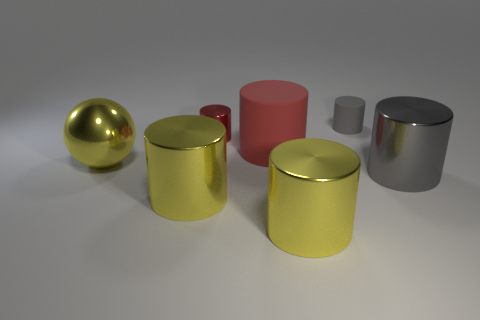Subtract all large rubber cylinders. How many cylinders are left? 5 Subtract all yellow cylinders. Subtract all green cubes. How many cylinders are left? 4 Add 1 purple rubber things. How many objects exist? 8 Subtract all cylinders. How many objects are left? 1 Add 4 tiny gray rubber cylinders. How many tiny gray rubber cylinders exist? 5 Subtract 0 gray spheres. How many objects are left? 7 Subtract all big yellow objects. Subtract all tiny green rubber objects. How many objects are left? 4 Add 5 large yellow shiny objects. How many large yellow shiny objects are left? 8 